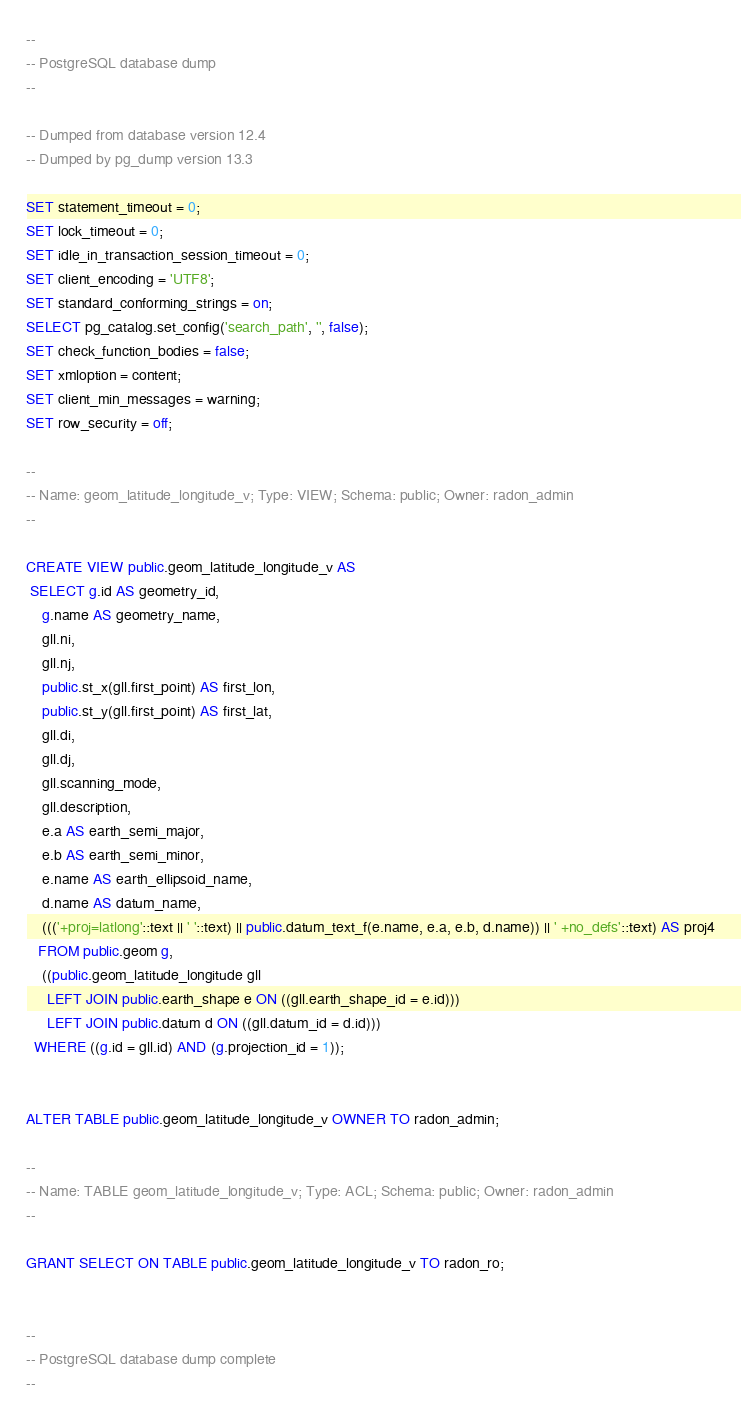<code> <loc_0><loc_0><loc_500><loc_500><_SQL_>--
-- PostgreSQL database dump
--

-- Dumped from database version 12.4
-- Dumped by pg_dump version 13.3

SET statement_timeout = 0;
SET lock_timeout = 0;
SET idle_in_transaction_session_timeout = 0;
SET client_encoding = 'UTF8';
SET standard_conforming_strings = on;
SELECT pg_catalog.set_config('search_path', '', false);
SET check_function_bodies = false;
SET xmloption = content;
SET client_min_messages = warning;
SET row_security = off;

--
-- Name: geom_latitude_longitude_v; Type: VIEW; Schema: public; Owner: radon_admin
--

CREATE VIEW public.geom_latitude_longitude_v AS
 SELECT g.id AS geometry_id,
    g.name AS geometry_name,
    gll.ni,
    gll.nj,
    public.st_x(gll.first_point) AS first_lon,
    public.st_y(gll.first_point) AS first_lat,
    gll.di,
    gll.dj,
    gll.scanning_mode,
    gll.description,
    e.a AS earth_semi_major,
    e.b AS earth_semi_minor,
    e.name AS earth_ellipsoid_name,
    d.name AS datum_name,
    ((('+proj=latlong'::text || ' '::text) || public.datum_text_f(e.name, e.a, e.b, d.name)) || ' +no_defs'::text) AS proj4
   FROM public.geom g,
    ((public.geom_latitude_longitude gll
     LEFT JOIN public.earth_shape e ON ((gll.earth_shape_id = e.id)))
     LEFT JOIN public.datum d ON ((gll.datum_id = d.id)))
  WHERE ((g.id = gll.id) AND (g.projection_id = 1));


ALTER TABLE public.geom_latitude_longitude_v OWNER TO radon_admin;

--
-- Name: TABLE geom_latitude_longitude_v; Type: ACL; Schema: public; Owner: radon_admin
--

GRANT SELECT ON TABLE public.geom_latitude_longitude_v TO radon_ro;


--
-- PostgreSQL database dump complete
--

</code> 